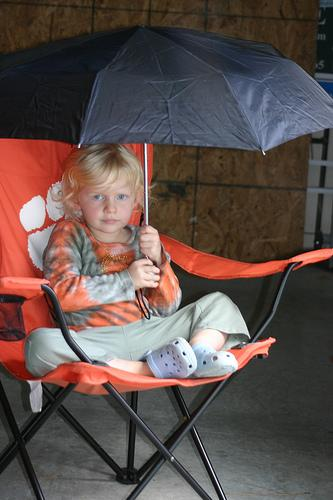Narrate an overview of the photograph and its elements. A young blonde child sits on an orange chair while holding a black umbrella, with plywood against the wall in the background, and croc shoes placed nearby on the floor. Mention the objects in the scenario along with their colors. A black open umbrella, small child in green pants and orange grey shirt, orange foldup chair with a paw print, and grey croc shoes on the cement floor. Illustrate the main actions performed by the child in the image. The child with wavy blonde hair is sitting comfortably in an orange folding chair while gripping a large, open black umbrella. Briefly describe the scene captured in the image. A young child with blonde hair and blue eyes is sitting on an orange foldup camp chair, holding a black open umbrella, while wearing green pants and an orange and grey shirt. Describe the main subject while focusing on their facial features. A young child with wavy blonde hair, bright blue eyes, and a youthful complexion sits holding a black umbrella. Sum up the image emphasizing on the background and the child's attire. A child donning green pants and an orange-grey shirt sits on an orange chair, with a plywood wall and cement floor serving as the backdrop. Provide a short account of the picture focusing on the child. A small child with blonde wavy hair and light blue eyes is seated in an orange foldup camp chair, holding a black umbrella and wearing comfy clothing. Give a concise description of the image, highlighting the main object. A young child with fair hair and blue eyes sits on an orange camp chair, holding a large, open black umbrella. Explain the setting of the image and the items present on the floor. In the setting with a plywood wall and cement floor, a young child sits on an orange chair while two grey croc shoes lie nearby. Write a brief depiction of the image focusing on the seated child and the chair. A young fair-haired child with blue eyes is nestled in an orange and black folding chair, grasping a wide black umbrella. 